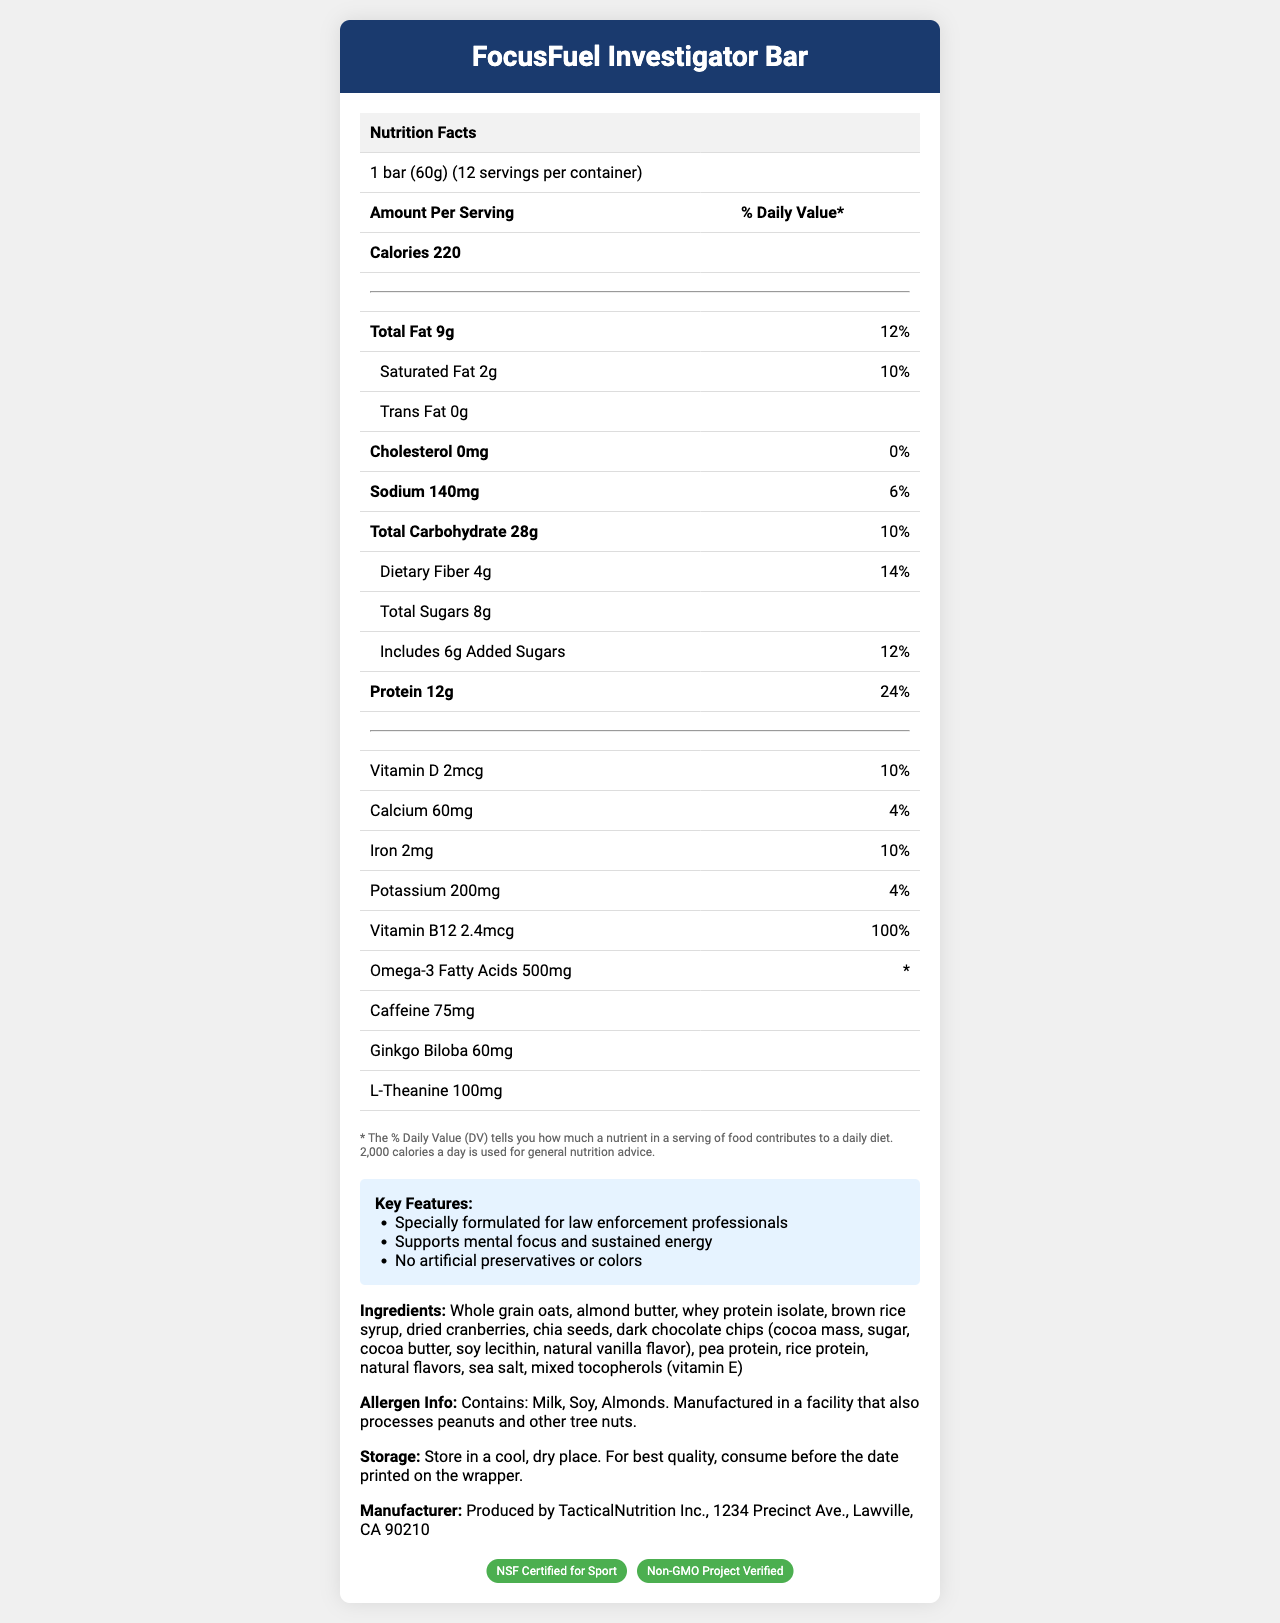what is the serving size of the FocusFuel Investigator Bar? The serving size is mentioned directly under the product name in the document.
Answer: 1 bar (60g) how many calories are there per serving? The number of calories per serving is listed under the "Amount Per Serving" section.
Answer: 220 how much protein does each serving contain? Each serving contains 12g of protein, as indicated in the nutrition facts table.
Answer: 12g what percentage of the daily value of Vitamin B12 does one serving provide? The document specifies that one serving provides 100% of the daily value of Vitamin B12.
Answer: 100% what ingredients are found in the FocusFuel Investigator Bar? The ingredients are listed under the heading "Ingredients" in the document.
Answer: Whole grain oats, almond butter, whey protein isolate, brown rice syrup, dried cranberries, chia seeds, dark chocolate chips (cocoa mass, sugar, cocoa butter, soy lecithin, natural vanilla flavor), pea protein, rice protein, natural flavors, sea salt, mixed tocopherols (vitamin E) which of the following nutrients is not listed in the document? A. Omega-3 Fatty Acids B. Vitamin C C. Ginkgo Biloba D. Caffeine Vitamin C is not listed in the document, while Omega-3 Fatty Acids, Ginkgo Biloba, and Caffeine are all mentioned.
Answer: B based on the nutritional information, which component has the highest percentage of daily value? A. Protein B. Sodium C. Dietary Fiber D. Vitamin B12 Vitamin B12 has the highest reported daily value percentage at 100%.
Answer: D Is the FocusFuel Investigator Bar NSF Certified for Sport? The certifications section indicates that it is NSF Certified for Sport.
Answer: Yes Is there any cholesterol in a serving of the FocusFuel Investigator Bar? The nutrition facts explicitly state that there is 0mg of cholesterol in a serving.
Answer: No Summarize the main features and purpose of the FocusFuel Investigator Bar. This explanation provides a detailed overview of the bar's benefits, targeted audience, nutritional profile, and certifications based on the document.
Answer: The FocusFuel Investigator Bar is a specialized energy bar formulated for law enforcement professionals to enhance mental focus during long investigative sessions. It contains a balanced mix of macronutrients and specific ingredients like caffeine, ginkgo biloba, and L-theanine that support cognitive performance. The bar is free from artificial preservatives and colors, contains significant amounts of protein and dietary fiber, and is certified by NSF for Sport and the Non-GMO Project. how many grams of total carbohydrates are there in one serving? The total carbohydrate content is listed as 28g per serving in the nutrition facts table.
Answer: 28g What is the percentage of the daily value for total fat in the FocusFuel Investigator Bar? The daily value percentage for total fat is listed as 12%.
Answer: 12% What is the caffeine content in each serving? The document states that each serving contains 75mg of caffeine.
Answer: 75mg What is the specific amount of Ginkgo Biloba in each bar? The amount of Ginkgo Biloba is listed as 60mg in the document.
Answer: 60mg What is the manufacturer's address for the FocusFuel Investigator Bar? The manufacturer address is provided under the manufacturer info section of the document.
Answer: 1234 Precinct Ave., Lawville, CA 90210 What is an included claim statement that supports the FocusFuel Investigator Bar's purpose? This claim is listed in the "Key Features" section and aligns with the bar's purpose to enhance mental focus.
Answer: Specially formulated for law enforcement professionals What date should the FocusFuel Investigator Bar be consumed by for best quality? The document states to "consume before the date printed on the wrapper," but does not provide a specific date.
Answer: Not enough information 